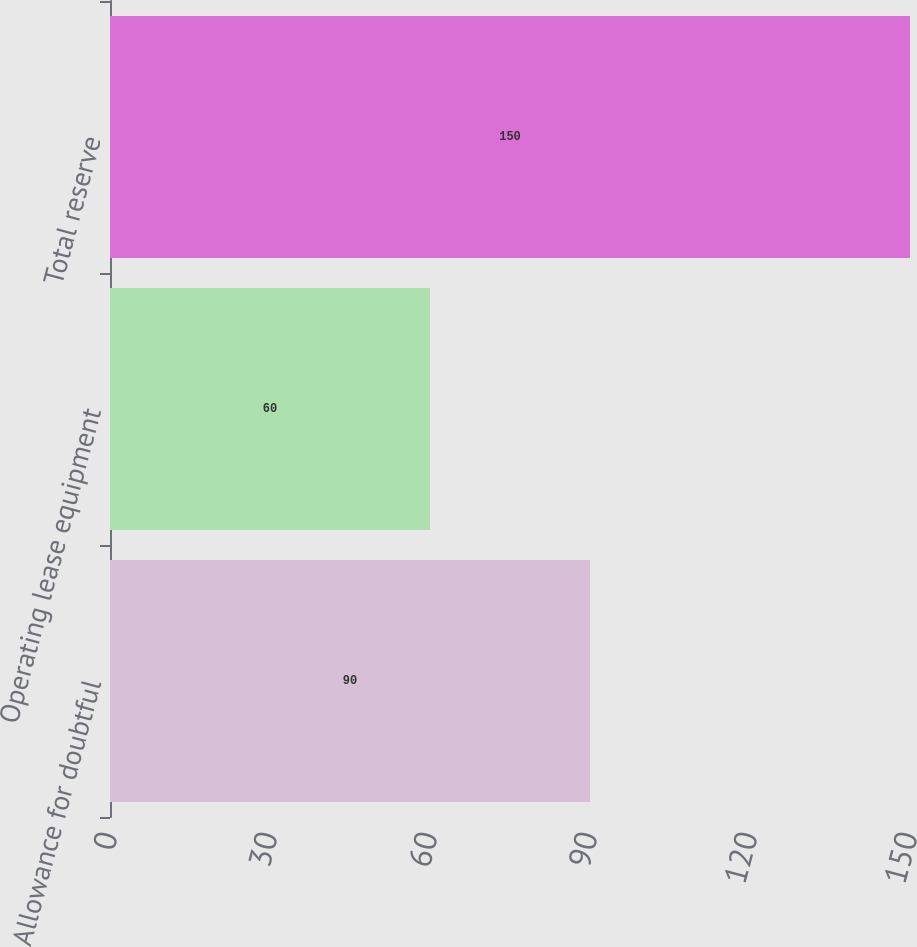Convert chart. <chart><loc_0><loc_0><loc_500><loc_500><bar_chart><fcel>Allowance for doubtful<fcel>Operating lease equipment<fcel>Total reserve<nl><fcel>90<fcel>60<fcel>150<nl></chart> 